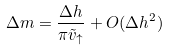<formula> <loc_0><loc_0><loc_500><loc_500>\Delta m = \frac { \Delta h } { \pi \tilde { v } _ { \uparrow } } + O ( \Delta h ^ { 2 } )</formula> 